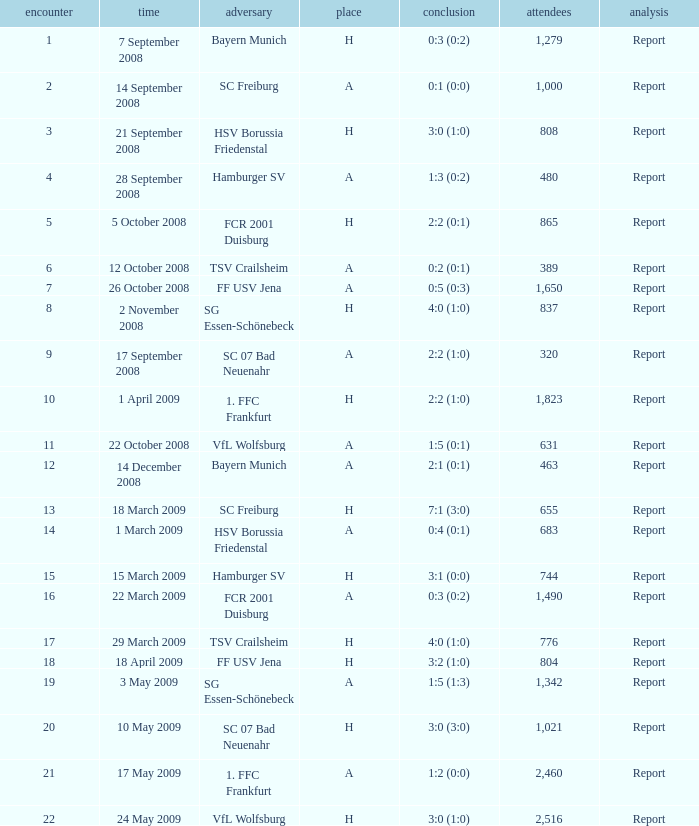What is the match number that had a result of 0:5 (0:3)? 1.0. 